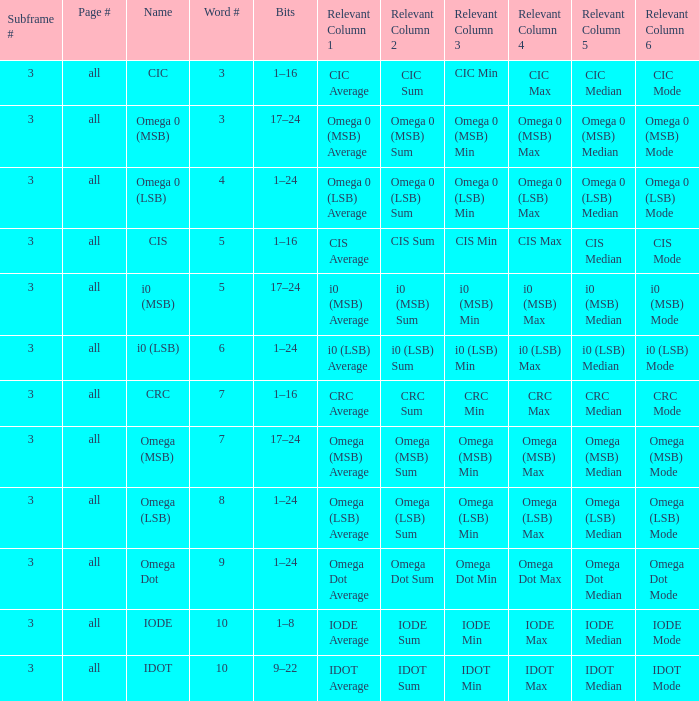What is the word count that is named omega dot? 9.0. 